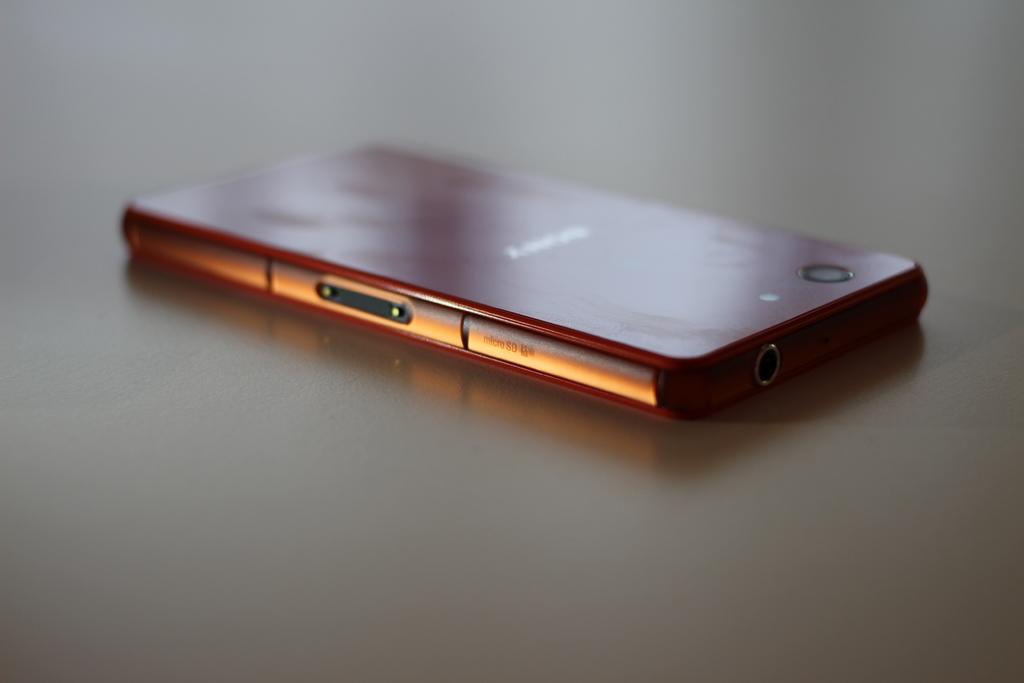Can you describe this image briefly? On this surface there is a mobile. 